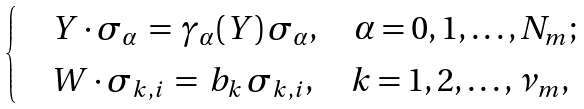<formula> <loc_0><loc_0><loc_500><loc_500>\begin{cases} & Y \cdot \sigma _ { \alpha } \, = \, \gamma _ { \alpha } ( Y ) \, \sigma _ { \alpha } , \quad \alpha = 0 , 1 , \dots , N _ { m } ; \\ & W \cdot \sigma _ { k , i } \, = \, b _ { k } \, \sigma _ { k , i } , \quad k = 1 , 2 , \dots , \nu _ { m } , \end{cases}</formula> 